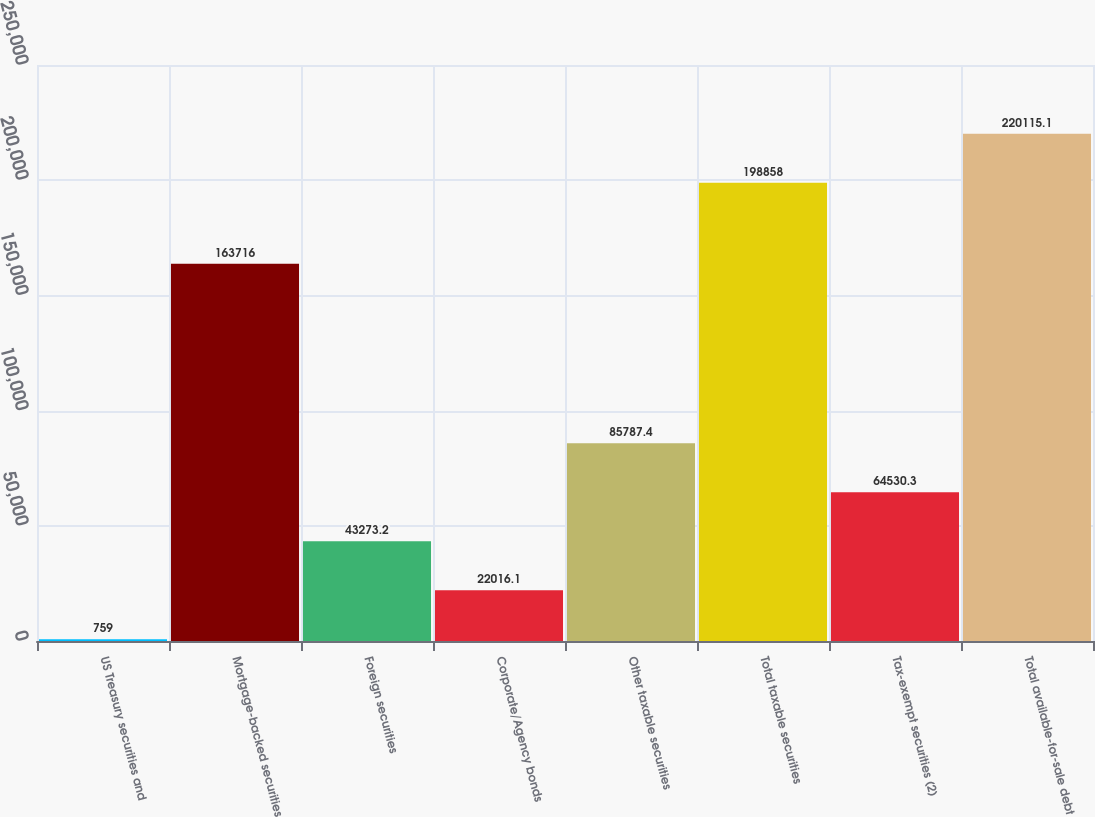<chart> <loc_0><loc_0><loc_500><loc_500><bar_chart><fcel>US Treasury securities and<fcel>Mortgage-backed securities<fcel>Foreign securities<fcel>Corporate/Agency bonds<fcel>Other taxable securities<fcel>Total taxable securities<fcel>Tax-exempt securities (2)<fcel>Total available-for-sale debt<nl><fcel>759<fcel>163716<fcel>43273.2<fcel>22016.1<fcel>85787.4<fcel>198858<fcel>64530.3<fcel>220115<nl></chart> 